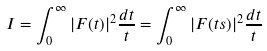<formula> <loc_0><loc_0><loc_500><loc_500>I = \int _ { 0 } ^ { \infty } | F ( t ) | ^ { 2 } \frac { d t } { t } = \int _ { 0 } ^ { \infty } | F ( t s ) | ^ { 2 } \frac { d t } { t }</formula> 